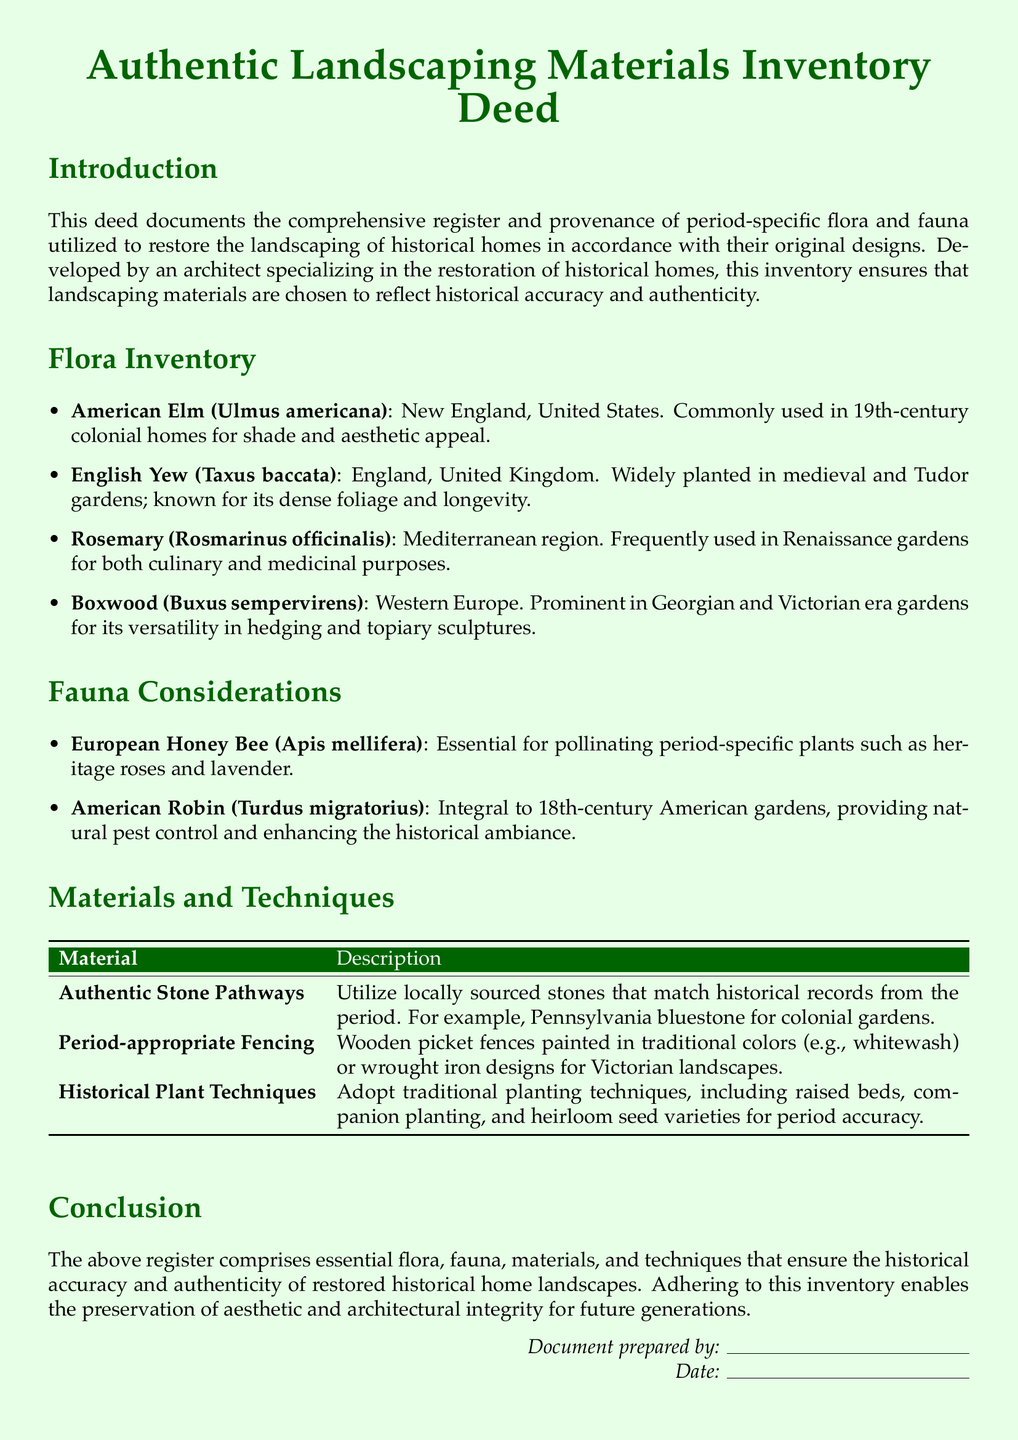What is the title of the document? The title of the document is stated at the top as "Authentic Landscaping Materials Inventory Deed."
Answer: Authentic Landscaping Materials Inventory Deed Who prepared the document? The document mentions the responsible party as "Document prepared by:" followed by a line.
Answer: Architect What is one example of flora used in the landscaping? The flora inventory lists several species, one of which is "American Elm."
Answer: American Elm In which region was the English Yew primarily utilized? The document specifies the region where English Yew was commonly planted as "England, United Kingdom."
Answer: England, United Kingdom How many fauna considerations are listed in the document? The document includes a section named "Fauna Considerations" which lists two examples.
Answer: Two What type of stones are recommended for authentic pathways? The document recommends "locally sourced stones" that match historical records such as "Pennsylvania bluestone."
Answer: Pennsylvania bluestone What planting techniques are suggested for historical accuracy? The document advises to "Adopt traditional planting techniques" including "raised beds" and "heirloom seed varieties."
Answer: Raised beds, heirloom seed varieties What is the color of the wooden picket fences suggested? The document states that wooden picket fences should be painted in "traditional colors" such as "whitewash."
Answer: Whitewash Which fauna is noted for pollinating period-specific plants? The document identifies the "European Honey Bee" as essential for pollinating specific plants.
Answer: European Honey Bee 